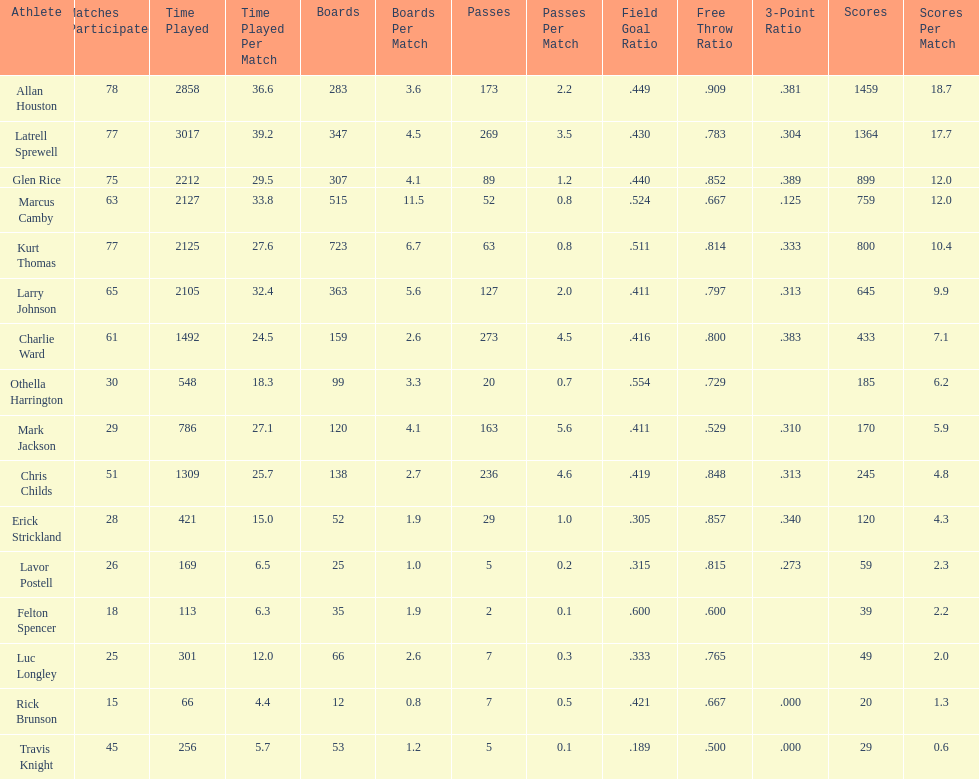How many players had a field goal percentage greater than .500? 4. Would you mind parsing the complete table? {'header': ['Athlete', 'Matches Participated', 'Time Played', 'Time Played Per Match', 'Boards', 'Boards Per Match', 'Passes', 'Passes Per Match', 'Field Goal Ratio', 'Free Throw Ratio', '3-Point Ratio', 'Scores', 'Scores Per Match'], 'rows': [['Allan Houston', '78', '2858', '36.6', '283', '3.6', '173', '2.2', '.449', '.909', '.381', '1459', '18.7'], ['Latrell Sprewell', '77', '3017', '39.2', '347', '4.5', '269', '3.5', '.430', '.783', '.304', '1364', '17.7'], ['Glen Rice', '75', '2212', '29.5', '307', '4.1', '89', '1.2', '.440', '.852', '.389', '899', '12.0'], ['Marcus Camby', '63', '2127', '33.8', '515', '11.5', '52', '0.8', '.524', '.667', '.125', '759', '12.0'], ['Kurt Thomas', '77', '2125', '27.6', '723', '6.7', '63', '0.8', '.511', '.814', '.333', '800', '10.4'], ['Larry Johnson', '65', '2105', '32.4', '363', '5.6', '127', '2.0', '.411', '.797', '.313', '645', '9.9'], ['Charlie Ward', '61', '1492', '24.5', '159', '2.6', '273', '4.5', '.416', '.800', '.383', '433', '7.1'], ['Othella Harrington', '30', '548', '18.3', '99', '3.3', '20', '0.7', '.554', '.729', '', '185', '6.2'], ['Mark Jackson', '29', '786', '27.1', '120', '4.1', '163', '5.6', '.411', '.529', '.310', '170', '5.9'], ['Chris Childs', '51', '1309', '25.7', '138', '2.7', '236', '4.6', '.419', '.848', '.313', '245', '4.8'], ['Erick Strickland', '28', '421', '15.0', '52', '1.9', '29', '1.0', '.305', '.857', '.340', '120', '4.3'], ['Lavor Postell', '26', '169', '6.5', '25', '1.0', '5', '0.2', '.315', '.815', '.273', '59', '2.3'], ['Felton Spencer', '18', '113', '6.3', '35', '1.9', '2', '0.1', '.600', '.600', '', '39', '2.2'], ['Luc Longley', '25', '301', '12.0', '66', '2.6', '7', '0.3', '.333', '.765', '', '49', '2.0'], ['Rick Brunson', '15', '66', '4.4', '12', '0.8', '7', '0.5', '.421', '.667', '.000', '20', '1.3'], ['Travis Knight', '45', '256', '5.7', '53', '1.2', '5', '0.1', '.189', '.500', '.000', '29', '0.6']]} 